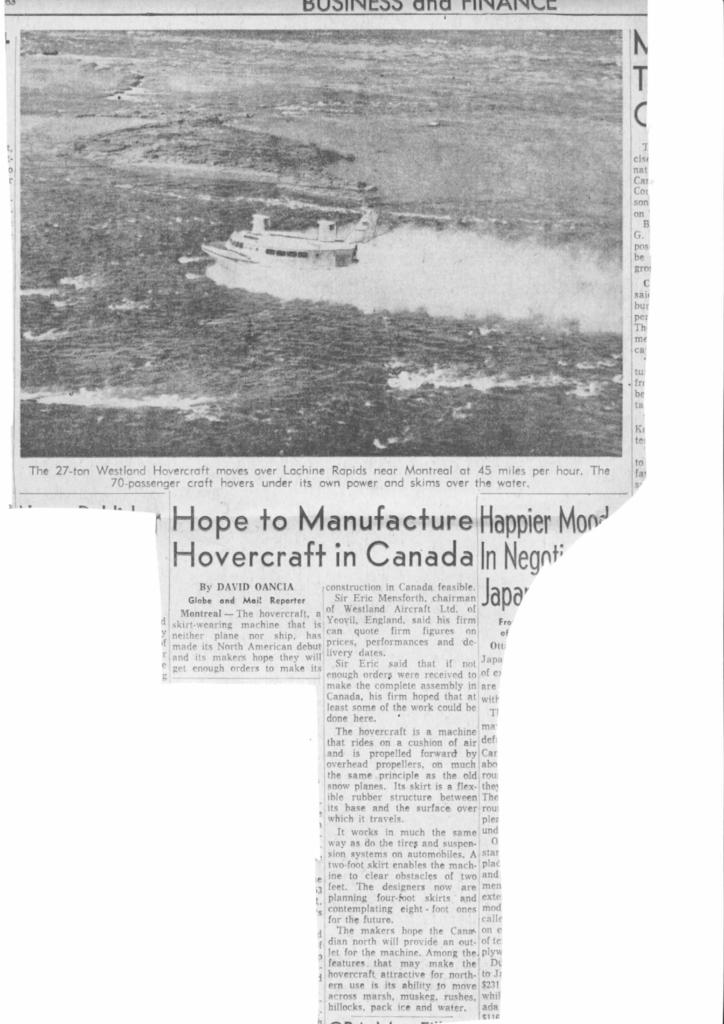What is the main object in the picture? There is a newspaper in the picture. What can be seen on the newspaper? The newspaper has a picture and text. What type of light is shining on the top of the slope in the image? There is no mention of a slope or light in the image; it only features a newspaper with a picture and text. 